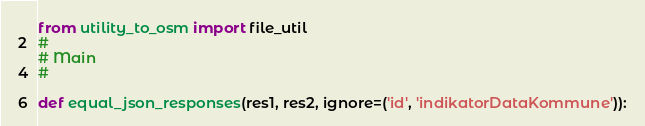Convert code to text. <code><loc_0><loc_0><loc_500><loc_500><_Python_>from utility_to_osm import file_util
#
# Main
#

def equal_json_responses(res1, res2, ignore=('id', 'indikatorDataKommune')):</code> 